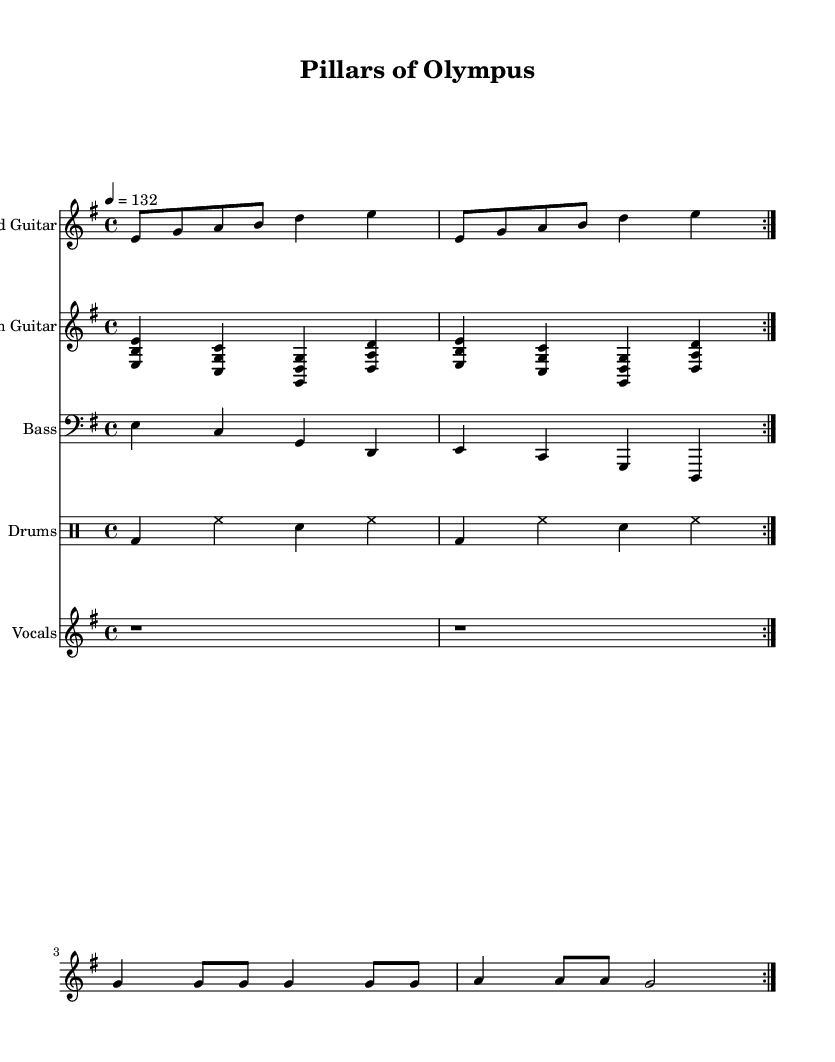What is the key signature of this music? The key signature is indicated at the beginning of the staff section and consists of one sharp, indicating E minor.
Answer: E minor What is the time signature of the piece? The time signature is found at the beginning of the score and is denoted as four beats per measure.
Answer: 4/4 What is the tempo marking for this piece? The tempo marking is shown in beats per minute at the start of the score, indicating a brisk pace of one hundred thirty-two beats.
Answer: 132 How many times is the lead guitar section repeated? The repeat markings in the lead guitar part clearly indicate that the section is played two times before moving on.
Answer: 2 What is the overall instrumentation of this composition? By analyzing the score, we can discern it includes lead guitar, rhythm guitar, bass, drums, and vocals, which are all listed in the score's sections.
Answer: Lead guitar, rhythm guitar, bass, drums, vocals What is the lyrical theme of the vocal section? The lyrics suggest an admiration of ancient architecture, specifically "towering columns" that evoke imagery of the Acropolis, indicating a theme centered around ancient Greek wonders.
Answer: Ancient architecture What type of guitar technique is used in the rhythm guitar part? The rhythm guitar part uses chordal strumming, indicated by the chord symbols showing simultaneous notes played together, typical in rock music.
Answer: Chordal strumming 